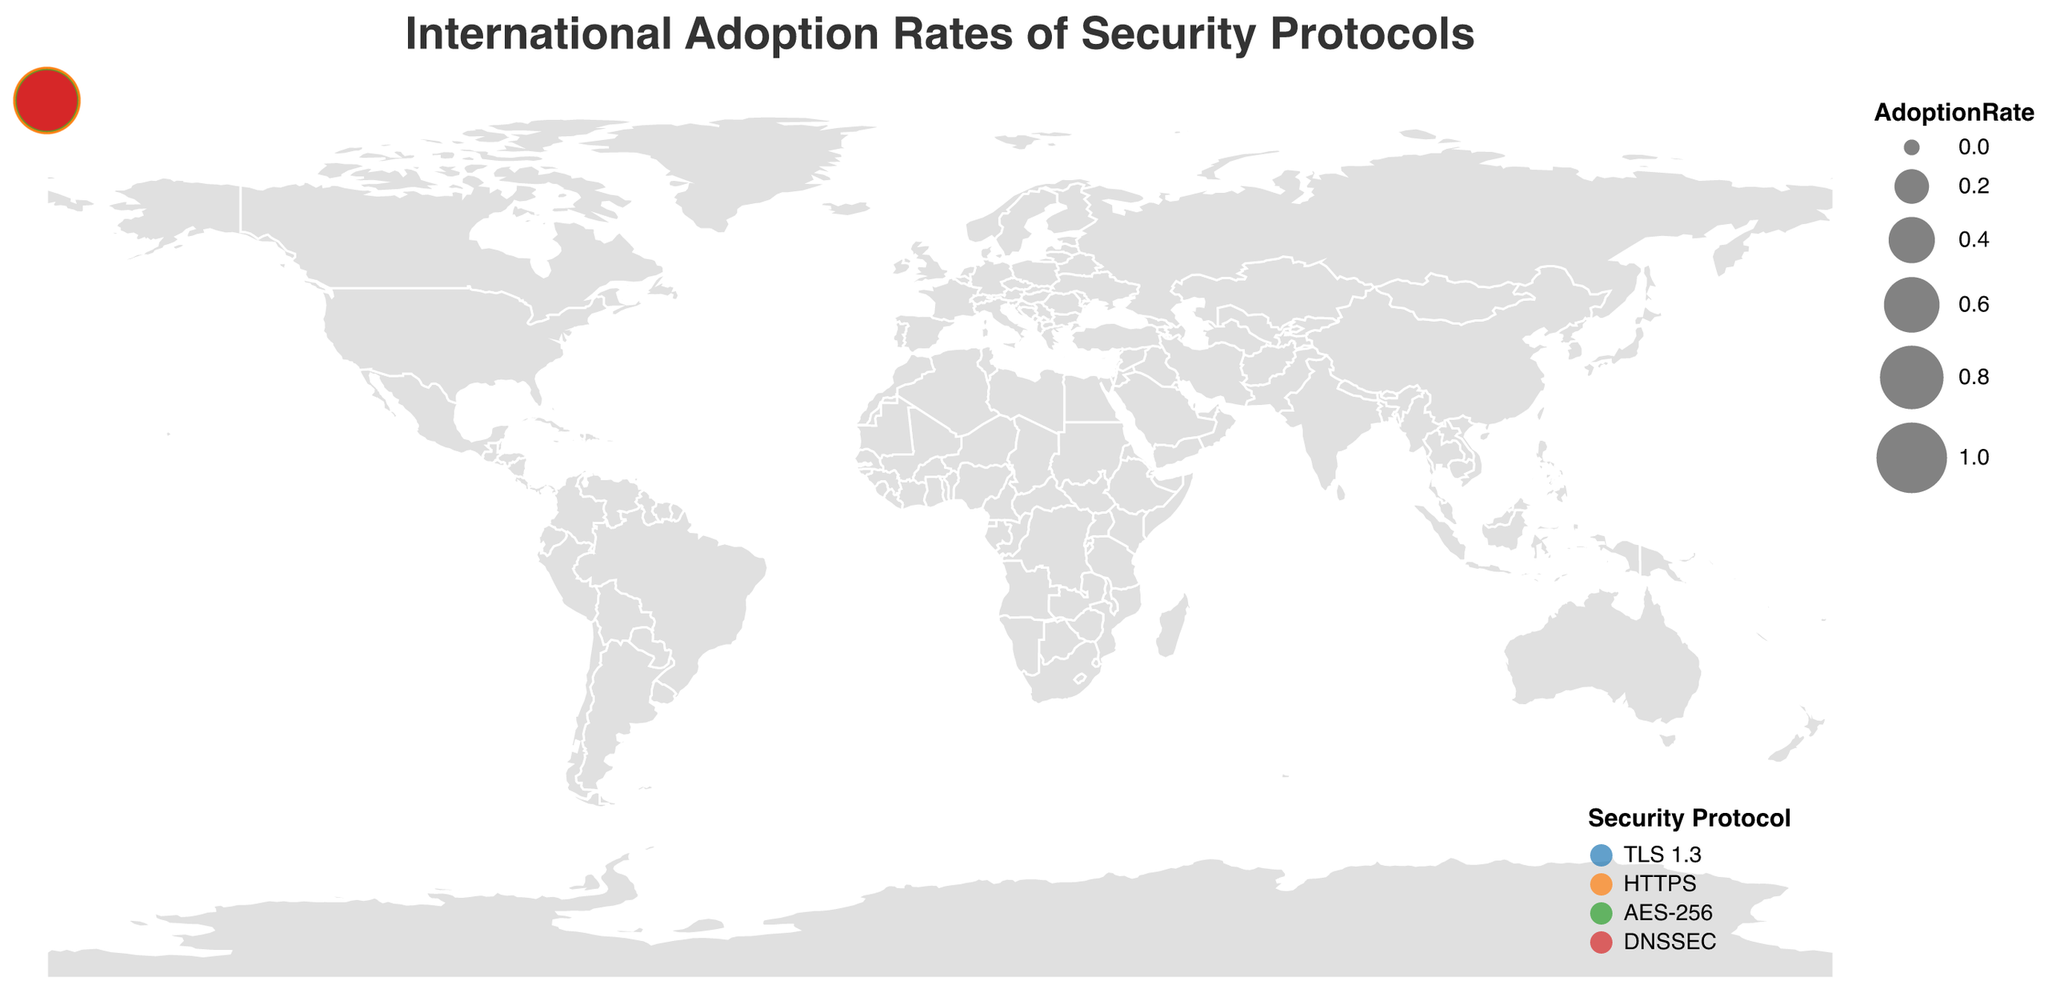What is the adoption rate of HTTPS in the United Kingdom? Look for the data point related to the United Kingdom and the protocol HTTPS. The adoption rate given is 0.92.
Answer: 0.92 Which country has the highest adoption rate for TLS 1.3? Check the adoption rates for TLS 1.3 across different countries. Germany has the highest adoption rate for TLS 1.3 at 0.82.
Answer: Germany What is the average adoption rate of DNSSEC across all listed countries? Find the adoption rates for DNSSEC: Sweden (0.68), Norway (0.71), Finland (0.73), Denmark (0.69), and Switzerland (0.66). Sum these up (0.68 + 0.71 + 0.73 + 0.69 + 0.66) = 3.47. Divide by the number of countries (5). The average is 3.47/5 = 0.694.
Answer: 0.694 How does the adoption rate of AES-256 in China compare to that in Russia? Check the adoption rates for AES-256 in both China (0.61) and Russia (0.57). The adoption rate in China is higher than in Russia.
Answer: Higher in China Which country has the lowest adoption rate for TLS 1.3, and what is the rate? Look at the TLS 1.3 adoption rates across countries: United States (0.78), Germany (0.82), Japan (0.65), Brazil (0.54), Australia (0.71). Brazil has the lowest adoption rate at 0.54.
Answer: Brazil - 0.54 What is the total number of security protocols visualized in the plot? Identify the unique security protocols mentioned: TLS 1.3, HTTPS, AES-256, DNSSEC. There are 4 unique protocols.
Answer: 4 Compare the adoption rates of HTTPS in Canada and France. Which country has a higher rate? Check the adoption rates for HTTPS in Canada (0.88) and France (0.89). France has a higher adoption rate than Canada.
Answer: France What is the difference in adoption rate for AES-256 between Italy and Spain? Find the adoption rates for AES-256 in Italy (0.72) and Spain (0.69). The difference is 0.72 - 0.69 = 0.03.
Answer: 0.03 Is the adoption rate of HTTPS in India higher or lower than 0.70? Compare India's HTTPS adoption rate (0.67) to 0.70. The adoption rate in India is lower than 0.70.
Answer: Lower Which region, Asia or Europe, has higher average adoption rates for AES-256? For Asia (China: 0.61, Russia: 0.57), the average is (0.61 + 0.57) / 2 = 0.59. For Europe (Italy: 0.72, Spain: 0.69, Netherlands: 0.79), the average is (0.72 + 0.69 + 0.79) / 3 = 0.733. Europe has a higher average adoption rate for AES-256.
Answer: Europe 